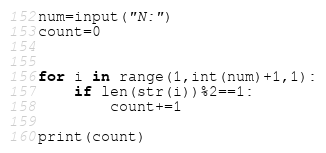<code> <loc_0><loc_0><loc_500><loc_500><_Python_>num=input("N:")
count=0


for i in range(1,int(num)+1,1):
    if len(str(i))%2==1:
        count+=1
        
print(count)
</code> 